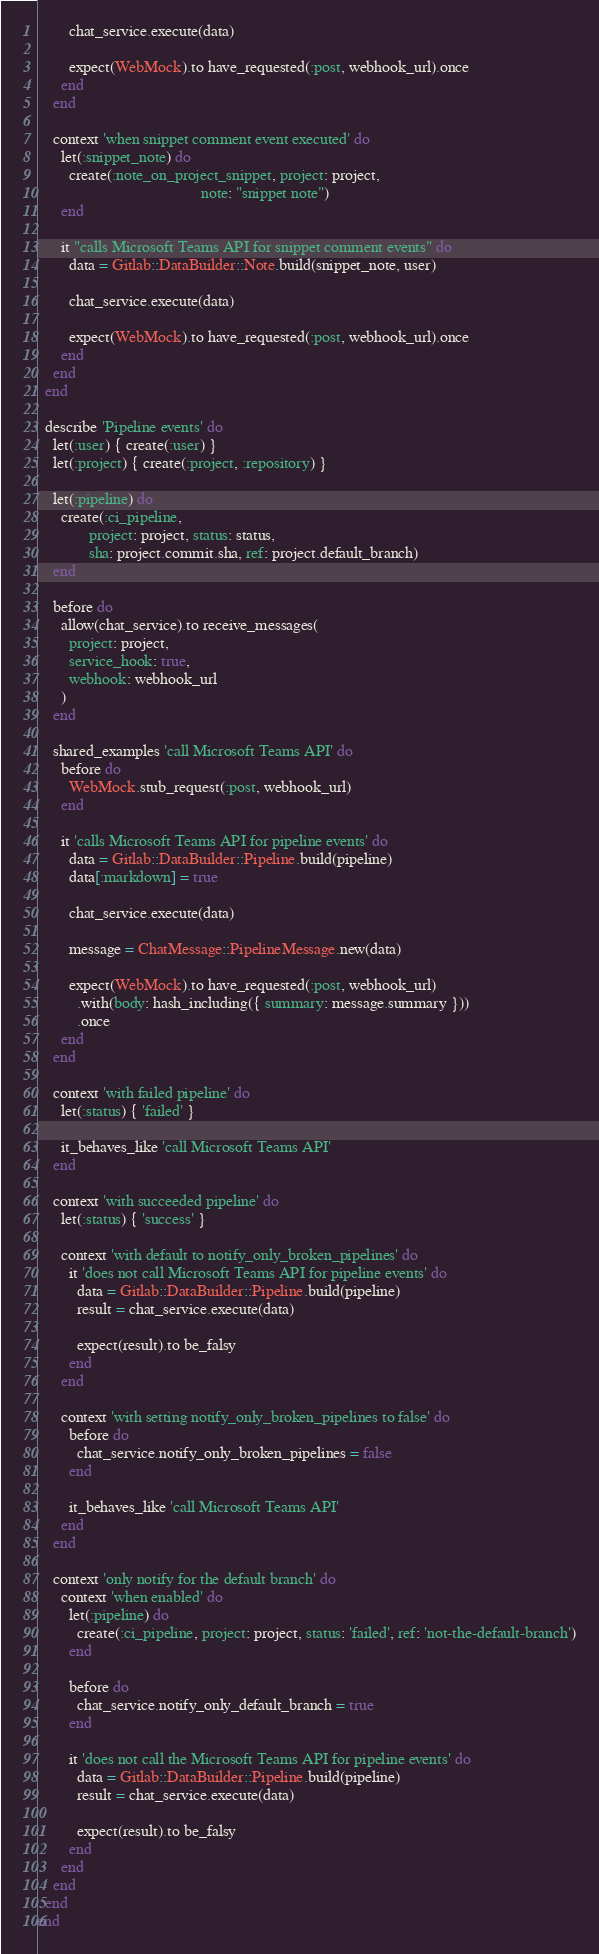<code> <loc_0><loc_0><loc_500><loc_500><_Ruby_>        chat_service.execute(data)

        expect(WebMock).to have_requested(:post, webhook_url).once
      end
    end

    context 'when snippet comment event executed' do
      let(:snippet_note) do
        create(:note_on_project_snippet, project: project,
                                         note: "snippet note")
      end

      it "calls Microsoft Teams API for snippet comment events" do
        data = Gitlab::DataBuilder::Note.build(snippet_note, user)

        chat_service.execute(data)

        expect(WebMock).to have_requested(:post, webhook_url).once
      end
    end
  end

  describe 'Pipeline events' do
    let(:user) { create(:user) }
    let(:project) { create(:project, :repository) }

    let(:pipeline) do
      create(:ci_pipeline,
             project: project, status: status,
             sha: project.commit.sha, ref: project.default_branch)
    end

    before do
      allow(chat_service).to receive_messages(
        project: project,
        service_hook: true,
        webhook: webhook_url
      )
    end

    shared_examples 'call Microsoft Teams API' do
      before do
        WebMock.stub_request(:post, webhook_url)
      end

      it 'calls Microsoft Teams API for pipeline events' do
        data = Gitlab::DataBuilder::Pipeline.build(pipeline)
        data[:markdown] = true

        chat_service.execute(data)

        message = ChatMessage::PipelineMessage.new(data)

        expect(WebMock).to have_requested(:post, webhook_url)
          .with(body: hash_including({ summary: message.summary }))
          .once
      end
    end

    context 'with failed pipeline' do
      let(:status) { 'failed' }

      it_behaves_like 'call Microsoft Teams API'
    end

    context 'with succeeded pipeline' do
      let(:status) { 'success' }

      context 'with default to notify_only_broken_pipelines' do
        it 'does not call Microsoft Teams API for pipeline events' do
          data = Gitlab::DataBuilder::Pipeline.build(pipeline)
          result = chat_service.execute(data)

          expect(result).to be_falsy
        end
      end

      context 'with setting notify_only_broken_pipelines to false' do
        before do
          chat_service.notify_only_broken_pipelines = false
        end

        it_behaves_like 'call Microsoft Teams API'
      end
    end

    context 'only notify for the default branch' do
      context 'when enabled' do
        let(:pipeline) do
          create(:ci_pipeline, project: project, status: 'failed', ref: 'not-the-default-branch')
        end

        before do
          chat_service.notify_only_default_branch = true
        end

        it 'does not call the Microsoft Teams API for pipeline events' do
          data = Gitlab::DataBuilder::Pipeline.build(pipeline)
          result = chat_service.execute(data)

          expect(result).to be_falsy
        end
      end
    end
  end
end
</code> 